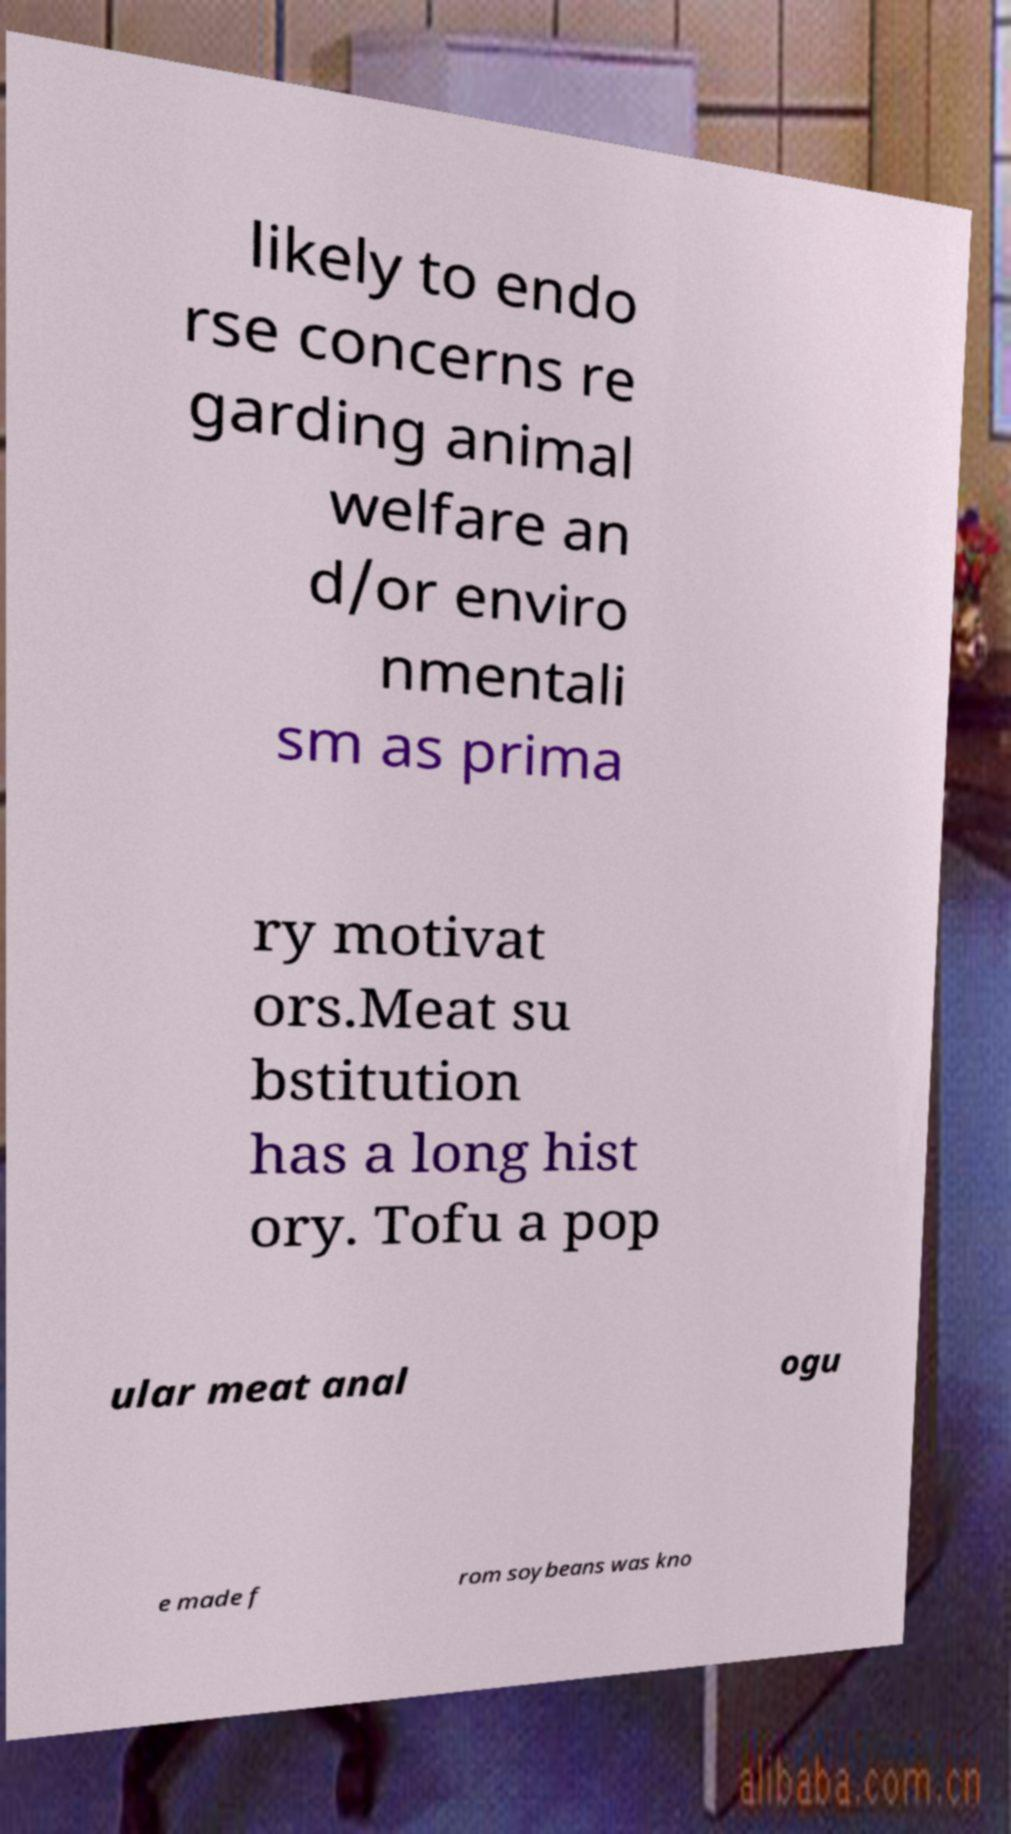Please identify and transcribe the text found in this image. likely to endo rse concerns re garding animal welfare an d/or enviro nmentali sm as prima ry motivat ors.Meat su bstitution has a long hist ory. Tofu a pop ular meat anal ogu e made f rom soybeans was kno 